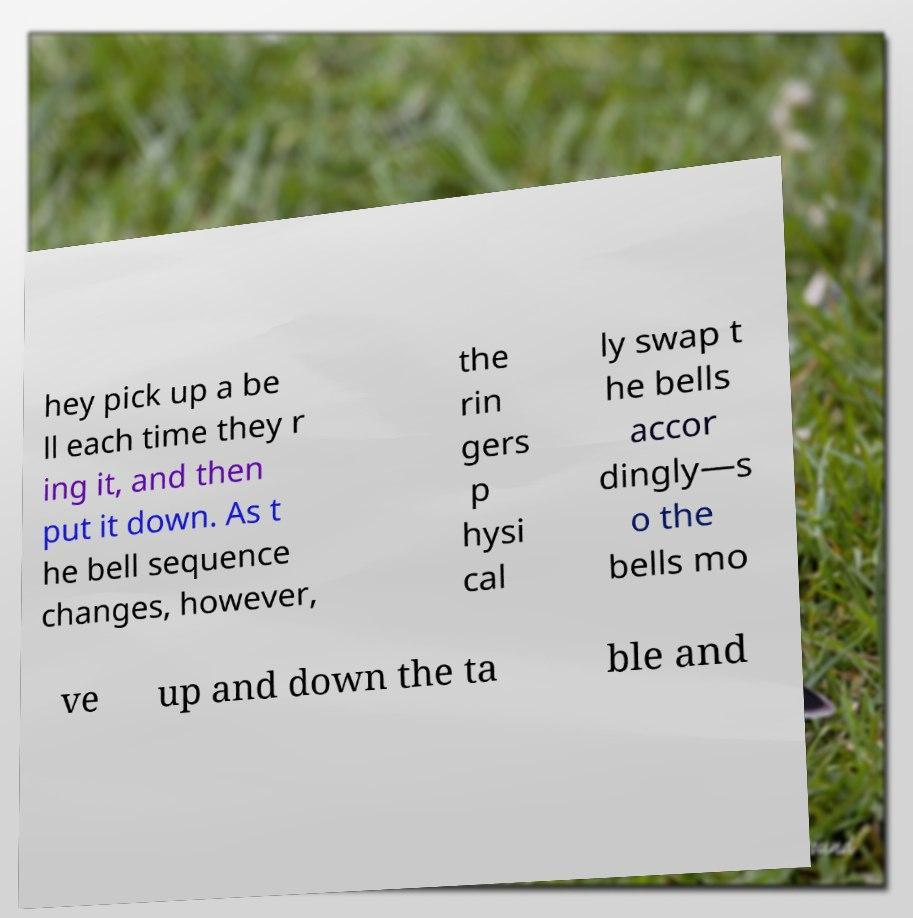Please read and relay the text visible in this image. What does it say? hey pick up a be ll each time they r ing it, and then put it down. As t he bell sequence changes, however, the rin gers p hysi cal ly swap t he bells accor dingly—s o the bells mo ve up and down the ta ble and 